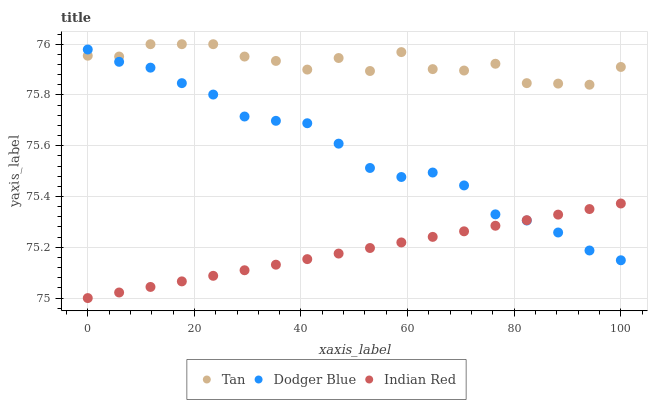Does Indian Red have the minimum area under the curve?
Answer yes or no. Yes. Does Tan have the maximum area under the curve?
Answer yes or no. Yes. Does Dodger Blue have the minimum area under the curve?
Answer yes or no. No. Does Dodger Blue have the maximum area under the curve?
Answer yes or no. No. Is Indian Red the smoothest?
Answer yes or no. Yes. Is Tan the roughest?
Answer yes or no. Yes. Is Dodger Blue the smoothest?
Answer yes or no. No. Is Dodger Blue the roughest?
Answer yes or no. No. Does Indian Red have the lowest value?
Answer yes or no. Yes. Does Dodger Blue have the lowest value?
Answer yes or no. No. Does Tan have the highest value?
Answer yes or no. Yes. Does Dodger Blue have the highest value?
Answer yes or no. No. Is Indian Red less than Tan?
Answer yes or no. Yes. Is Tan greater than Indian Red?
Answer yes or no. Yes. Does Dodger Blue intersect Indian Red?
Answer yes or no. Yes. Is Dodger Blue less than Indian Red?
Answer yes or no. No. Is Dodger Blue greater than Indian Red?
Answer yes or no. No. Does Indian Red intersect Tan?
Answer yes or no. No. 